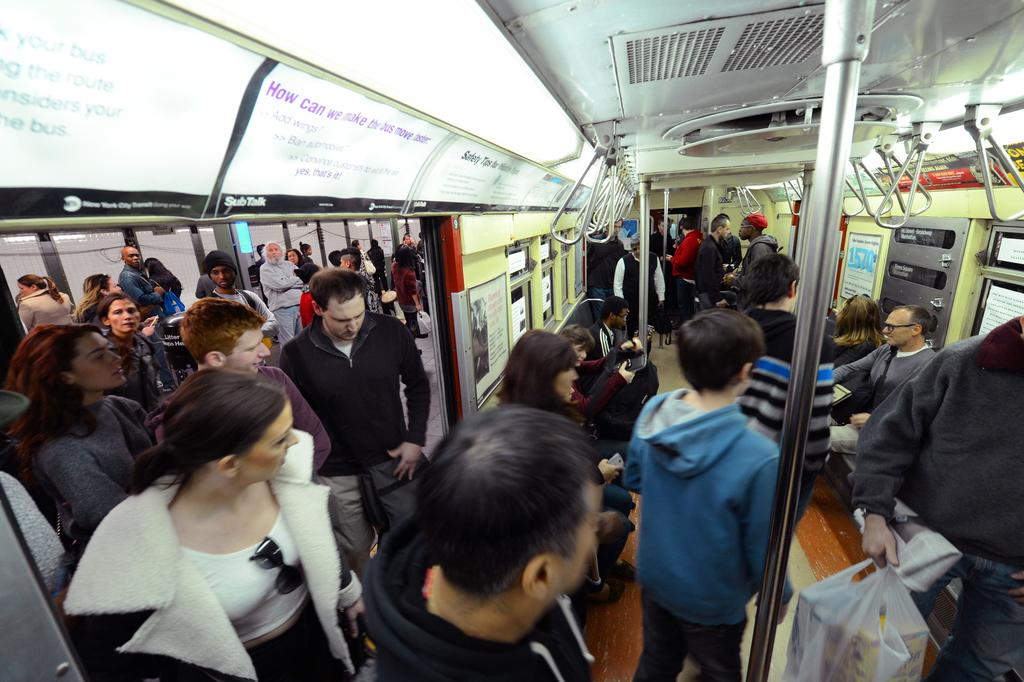Who is present in the image? There are people in the image. What are the people doing in the image? The people are standing in a train. How many babies are present in the image? There is no information about babies in the image, so we cannot determine their number. 